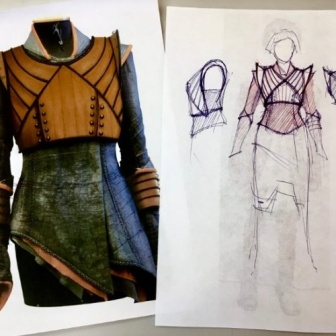Can you speculate on the possible inspiration behind the design of this dress? The inspiration behind the dress seems to draw from a fusion of historical and fantasy elements. The high collar and use of rivets could be reminiscent of a suit of armor, suggesting a nod to medieval or fantasy warrior attire. The earth-toned color scheme and layering could evoke the organic armor of a fantasy forest guardian. Collectively, this suggests that the designer might be inspired by strong, protective themes paired with an aesthetic that embraces both the archaic and the mythical. 